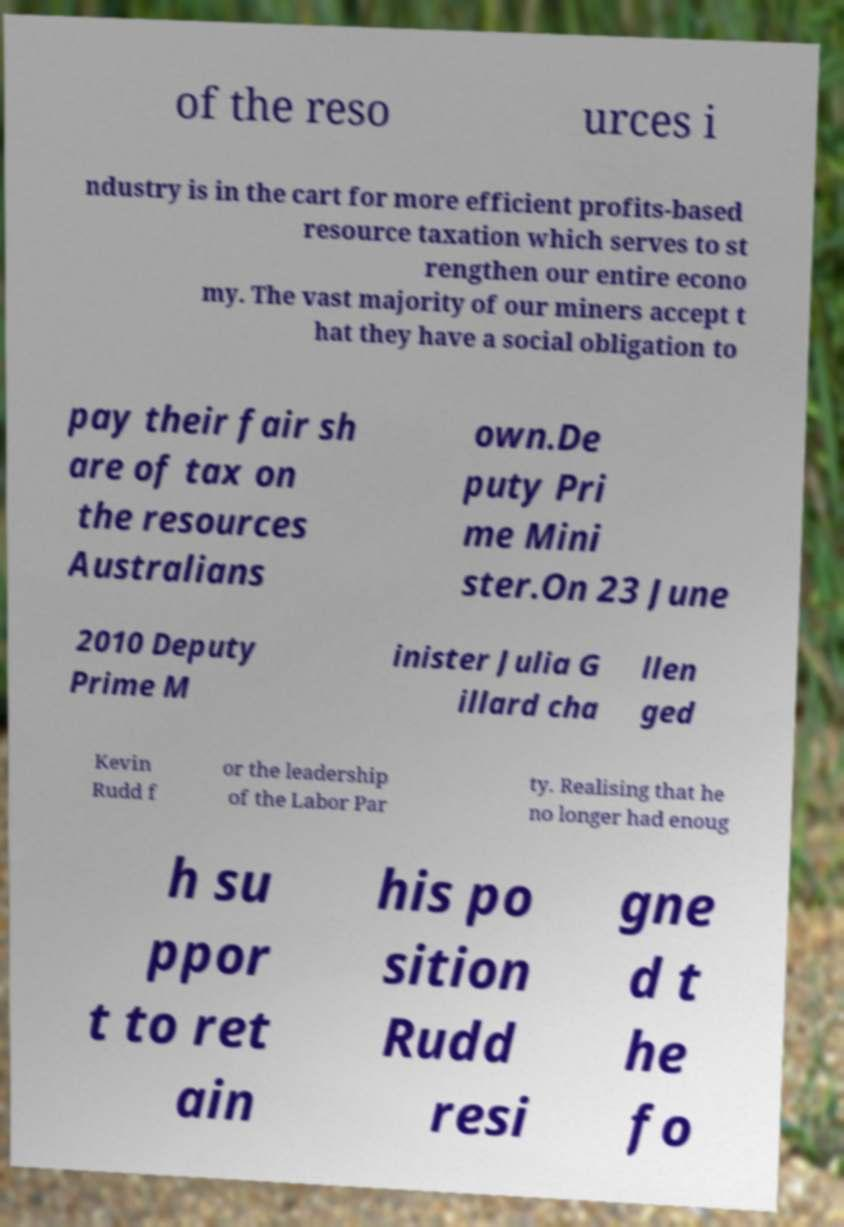Please read and relay the text visible in this image. What does it say? of the reso urces i ndustry is in the cart for more efficient profits-based resource taxation which serves to st rengthen our entire econo my. The vast majority of our miners accept t hat they have a social obligation to pay their fair sh are of tax on the resources Australians own.De puty Pri me Mini ster.On 23 June 2010 Deputy Prime M inister Julia G illard cha llen ged Kevin Rudd f or the leadership of the Labor Par ty. Realising that he no longer had enoug h su ppor t to ret ain his po sition Rudd resi gne d t he fo 